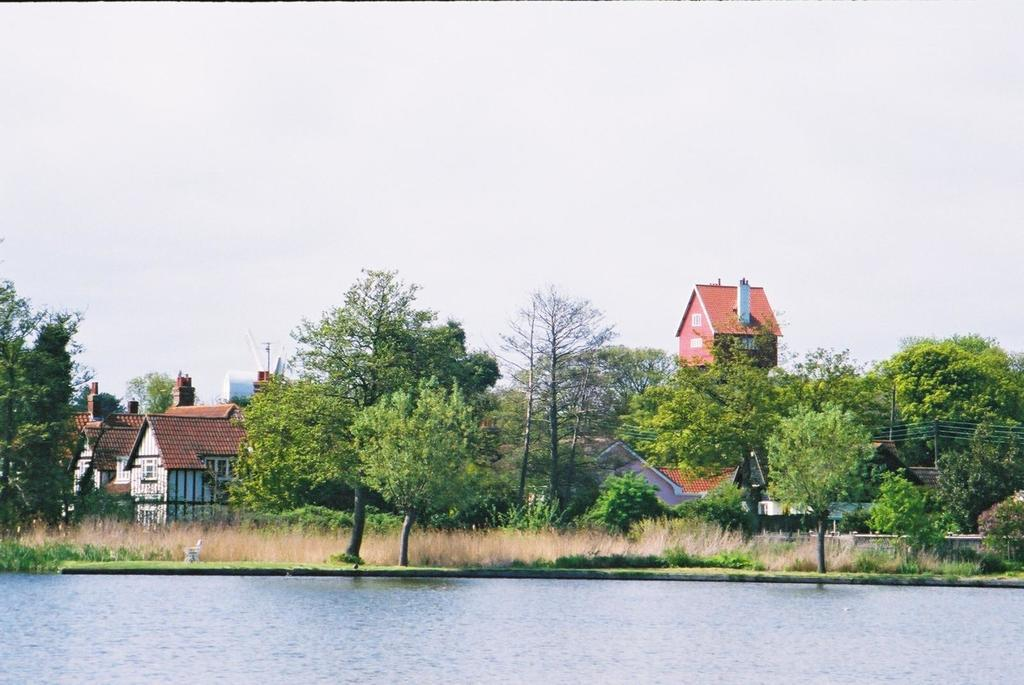What is present at the bottom of the image? There is water at the bottom of the image. What can be seen in the middle of the image? There are trees and buildings in the middle of the image. What is visible at the top of the image? The sky is visible at the top of the image. What type of string is being used to hold up the trees in the image? There is no string present in the image; the trees are standing on their own. What color is the lead that is being used to draw the buildings in the image? There is no lead present in the image; the buildings are depicted as solid structures. 